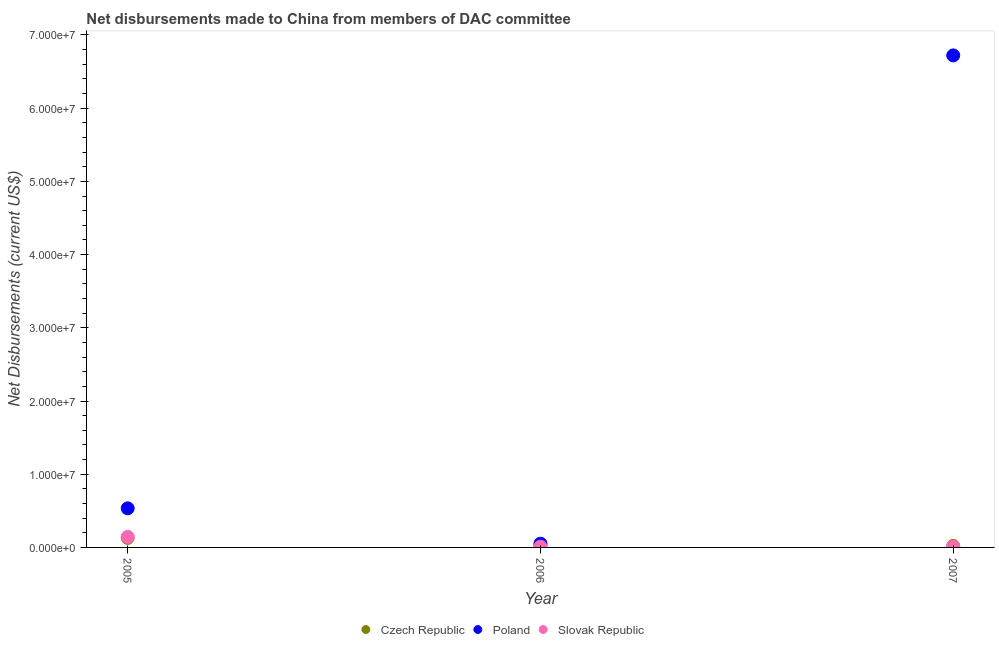How many different coloured dotlines are there?
Your response must be concise. 3. Is the number of dotlines equal to the number of legend labels?
Make the answer very short. Yes. What is the net disbursements made by czech republic in 2007?
Offer a very short reply. 2.10e+05. Across all years, what is the maximum net disbursements made by slovak republic?
Your answer should be very brief. 1.44e+06. Across all years, what is the minimum net disbursements made by slovak republic?
Provide a short and direct response. 9.00e+04. In which year was the net disbursements made by czech republic minimum?
Offer a terse response. 2007. What is the total net disbursements made by slovak republic in the graph?
Provide a short and direct response. 1.63e+06. What is the difference between the net disbursements made by poland in 2005 and that in 2006?
Provide a succinct answer. 4.83e+06. What is the difference between the net disbursements made by poland in 2007 and the net disbursements made by slovak republic in 2006?
Provide a short and direct response. 6.71e+07. What is the average net disbursements made by slovak republic per year?
Ensure brevity in your answer.  5.43e+05. In the year 2007, what is the difference between the net disbursements made by poland and net disbursements made by czech republic?
Make the answer very short. 6.70e+07. In how many years, is the net disbursements made by czech republic greater than 54000000 US$?
Offer a very short reply. 0. What is the ratio of the net disbursements made by poland in 2006 to that in 2007?
Provide a short and direct response. 0.01. What is the difference between the highest and the second highest net disbursements made by poland?
Ensure brevity in your answer.  6.19e+07. What is the difference between the highest and the lowest net disbursements made by slovak republic?
Your answer should be very brief. 1.35e+06. In how many years, is the net disbursements made by czech republic greater than the average net disbursements made by czech republic taken over all years?
Offer a terse response. 1. Is it the case that in every year, the sum of the net disbursements made by czech republic and net disbursements made by poland is greater than the net disbursements made by slovak republic?
Make the answer very short. Yes. Is the net disbursements made by slovak republic strictly greater than the net disbursements made by czech republic over the years?
Give a very brief answer. No. How many dotlines are there?
Provide a short and direct response. 3. What is the difference between two consecutive major ticks on the Y-axis?
Ensure brevity in your answer.  1.00e+07. Are the values on the major ticks of Y-axis written in scientific E-notation?
Your answer should be compact. Yes. Does the graph contain grids?
Keep it short and to the point. No. How many legend labels are there?
Keep it short and to the point. 3. How are the legend labels stacked?
Ensure brevity in your answer.  Horizontal. What is the title of the graph?
Your answer should be compact. Net disbursements made to China from members of DAC committee. Does "Secondary education" appear as one of the legend labels in the graph?
Offer a terse response. No. What is the label or title of the X-axis?
Keep it short and to the point. Year. What is the label or title of the Y-axis?
Keep it short and to the point. Net Disbursements (current US$). What is the Net Disbursements (current US$) in Czech Republic in 2005?
Offer a very short reply. 1.30e+06. What is the Net Disbursements (current US$) in Poland in 2005?
Offer a terse response. 5.34e+06. What is the Net Disbursements (current US$) in Slovak Republic in 2005?
Provide a short and direct response. 1.44e+06. What is the Net Disbursements (current US$) of Czech Republic in 2006?
Your response must be concise. 3.40e+05. What is the Net Disbursements (current US$) in Poland in 2006?
Ensure brevity in your answer.  5.10e+05. What is the Net Disbursements (current US$) in Slovak Republic in 2006?
Ensure brevity in your answer.  9.00e+04. What is the Net Disbursements (current US$) of Czech Republic in 2007?
Your response must be concise. 2.10e+05. What is the Net Disbursements (current US$) in Poland in 2007?
Keep it short and to the point. 6.72e+07. What is the Net Disbursements (current US$) in Slovak Republic in 2007?
Ensure brevity in your answer.  1.00e+05. Across all years, what is the maximum Net Disbursements (current US$) of Czech Republic?
Ensure brevity in your answer.  1.30e+06. Across all years, what is the maximum Net Disbursements (current US$) of Poland?
Keep it short and to the point. 6.72e+07. Across all years, what is the maximum Net Disbursements (current US$) in Slovak Republic?
Your answer should be very brief. 1.44e+06. Across all years, what is the minimum Net Disbursements (current US$) of Poland?
Your answer should be very brief. 5.10e+05. Across all years, what is the minimum Net Disbursements (current US$) in Slovak Republic?
Your response must be concise. 9.00e+04. What is the total Net Disbursements (current US$) of Czech Republic in the graph?
Keep it short and to the point. 1.85e+06. What is the total Net Disbursements (current US$) of Poland in the graph?
Keep it short and to the point. 7.31e+07. What is the total Net Disbursements (current US$) in Slovak Republic in the graph?
Offer a terse response. 1.63e+06. What is the difference between the Net Disbursements (current US$) of Czech Republic in 2005 and that in 2006?
Make the answer very short. 9.60e+05. What is the difference between the Net Disbursements (current US$) of Poland in 2005 and that in 2006?
Give a very brief answer. 4.83e+06. What is the difference between the Net Disbursements (current US$) of Slovak Republic in 2005 and that in 2006?
Provide a succinct answer. 1.35e+06. What is the difference between the Net Disbursements (current US$) of Czech Republic in 2005 and that in 2007?
Provide a short and direct response. 1.09e+06. What is the difference between the Net Disbursements (current US$) in Poland in 2005 and that in 2007?
Provide a succinct answer. -6.19e+07. What is the difference between the Net Disbursements (current US$) in Slovak Republic in 2005 and that in 2007?
Ensure brevity in your answer.  1.34e+06. What is the difference between the Net Disbursements (current US$) of Czech Republic in 2006 and that in 2007?
Your answer should be very brief. 1.30e+05. What is the difference between the Net Disbursements (current US$) in Poland in 2006 and that in 2007?
Provide a short and direct response. -6.67e+07. What is the difference between the Net Disbursements (current US$) in Slovak Republic in 2006 and that in 2007?
Your answer should be very brief. -10000. What is the difference between the Net Disbursements (current US$) in Czech Republic in 2005 and the Net Disbursements (current US$) in Poland in 2006?
Make the answer very short. 7.90e+05. What is the difference between the Net Disbursements (current US$) of Czech Republic in 2005 and the Net Disbursements (current US$) of Slovak Republic in 2006?
Offer a terse response. 1.21e+06. What is the difference between the Net Disbursements (current US$) of Poland in 2005 and the Net Disbursements (current US$) of Slovak Republic in 2006?
Offer a terse response. 5.25e+06. What is the difference between the Net Disbursements (current US$) in Czech Republic in 2005 and the Net Disbursements (current US$) in Poland in 2007?
Ensure brevity in your answer.  -6.59e+07. What is the difference between the Net Disbursements (current US$) in Czech Republic in 2005 and the Net Disbursements (current US$) in Slovak Republic in 2007?
Make the answer very short. 1.20e+06. What is the difference between the Net Disbursements (current US$) in Poland in 2005 and the Net Disbursements (current US$) in Slovak Republic in 2007?
Your answer should be very brief. 5.24e+06. What is the difference between the Net Disbursements (current US$) in Czech Republic in 2006 and the Net Disbursements (current US$) in Poland in 2007?
Offer a very short reply. -6.69e+07. What is the difference between the Net Disbursements (current US$) of Czech Republic in 2006 and the Net Disbursements (current US$) of Slovak Republic in 2007?
Your response must be concise. 2.40e+05. What is the difference between the Net Disbursements (current US$) in Poland in 2006 and the Net Disbursements (current US$) in Slovak Republic in 2007?
Give a very brief answer. 4.10e+05. What is the average Net Disbursements (current US$) of Czech Republic per year?
Your answer should be very brief. 6.17e+05. What is the average Net Disbursements (current US$) in Poland per year?
Make the answer very short. 2.44e+07. What is the average Net Disbursements (current US$) in Slovak Republic per year?
Your response must be concise. 5.43e+05. In the year 2005, what is the difference between the Net Disbursements (current US$) of Czech Republic and Net Disbursements (current US$) of Poland?
Keep it short and to the point. -4.04e+06. In the year 2005, what is the difference between the Net Disbursements (current US$) of Czech Republic and Net Disbursements (current US$) of Slovak Republic?
Keep it short and to the point. -1.40e+05. In the year 2005, what is the difference between the Net Disbursements (current US$) of Poland and Net Disbursements (current US$) of Slovak Republic?
Provide a short and direct response. 3.90e+06. In the year 2006, what is the difference between the Net Disbursements (current US$) in Czech Republic and Net Disbursements (current US$) in Slovak Republic?
Offer a very short reply. 2.50e+05. In the year 2006, what is the difference between the Net Disbursements (current US$) of Poland and Net Disbursements (current US$) of Slovak Republic?
Your response must be concise. 4.20e+05. In the year 2007, what is the difference between the Net Disbursements (current US$) of Czech Republic and Net Disbursements (current US$) of Poland?
Offer a very short reply. -6.70e+07. In the year 2007, what is the difference between the Net Disbursements (current US$) of Czech Republic and Net Disbursements (current US$) of Slovak Republic?
Offer a terse response. 1.10e+05. In the year 2007, what is the difference between the Net Disbursements (current US$) in Poland and Net Disbursements (current US$) in Slovak Republic?
Keep it short and to the point. 6.71e+07. What is the ratio of the Net Disbursements (current US$) in Czech Republic in 2005 to that in 2006?
Keep it short and to the point. 3.82. What is the ratio of the Net Disbursements (current US$) of Poland in 2005 to that in 2006?
Offer a terse response. 10.47. What is the ratio of the Net Disbursements (current US$) in Czech Republic in 2005 to that in 2007?
Give a very brief answer. 6.19. What is the ratio of the Net Disbursements (current US$) of Poland in 2005 to that in 2007?
Give a very brief answer. 0.08. What is the ratio of the Net Disbursements (current US$) in Czech Republic in 2006 to that in 2007?
Your answer should be compact. 1.62. What is the ratio of the Net Disbursements (current US$) of Poland in 2006 to that in 2007?
Provide a succinct answer. 0.01. What is the difference between the highest and the second highest Net Disbursements (current US$) in Czech Republic?
Provide a short and direct response. 9.60e+05. What is the difference between the highest and the second highest Net Disbursements (current US$) in Poland?
Your response must be concise. 6.19e+07. What is the difference between the highest and the second highest Net Disbursements (current US$) of Slovak Republic?
Ensure brevity in your answer.  1.34e+06. What is the difference between the highest and the lowest Net Disbursements (current US$) of Czech Republic?
Ensure brevity in your answer.  1.09e+06. What is the difference between the highest and the lowest Net Disbursements (current US$) in Poland?
Your answer should be compact. 6.67e+07. What is the difference between the highest and the lowest Net Disbursements (current US$) of Slovak Republic?
Ensure brevity in your answer.  1.35e+06. 